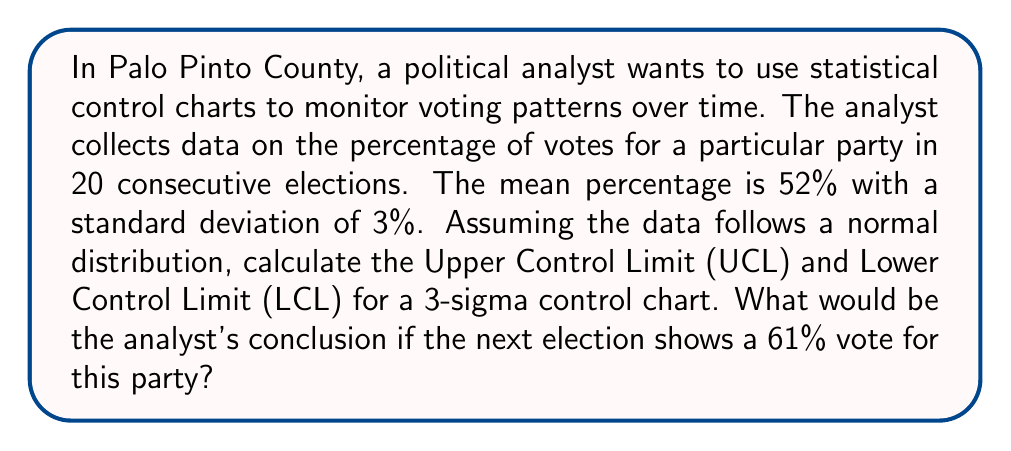Help me with this question. To analyze voting patterns using statistical control methods, we can use a 3-sigma control chart. This method helps identify when a process (in this case, voting patterns) is out of statistical control.

Step 1: Calculate the Upper Control Limit (UCL)
The UCL is calculated as: $\text{UCL} = \mu + 3\sigma$
Where $\mu$ is the mean and $\sigma$ is the standard deviation.

$\text{UCL} = 52\% + 3(3\%) = 52\% + 9\% = 61\%$

Step 2: Calculate the Lower Control Limit (LCL)
The LCL is calculated as: $\text{LCL} = \mu - 3\sigma$

$\text{LCL} = 52\% - 3(3\%) = 52\% - 9\% = 43\%$

Step 3: Interpret the results
The control limits define the range within which 99.73% of the data points should fall if the process is in statistical control. Any point outside these limits is considered a special cause variation.

In this case:
UCL = 61%
LCL = 43%

If the next election shows a 61% vote for this party, it would be exactly at the Upper Control Limit. While this is technically within the control limits, it is at the very edge and would warrant close attention. It suggests that the voting pattern might be shifting towards favoring this party more than usual.

In practice, many analysts would treat this as a signal of potential change, especially if it's followed by other high percentages in subsequent elections. It could indicate a shift in voter preferences or other factors influencing the election outcomes in Palo Pinto County.
Answer: UCL = 61%, LCL = 43%. A 61% vote in the next election would be at the Upper Control Limit, indicating a potential shift in voting patterns that requires further monitoring. 